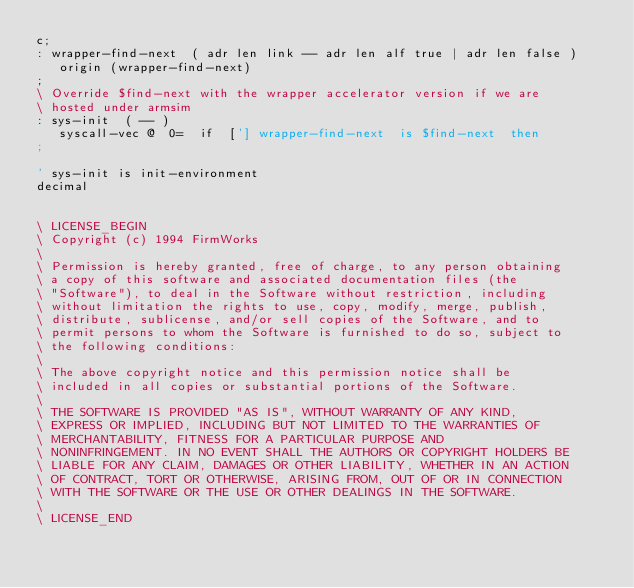<code> <loc_0><loc_0><loc_500><loc_500><_Forth_>c;
: wrapper-find-next  ( adr len link -- adr len alf true | adr len false )
   origin (wrapper-find-next)
;
\ Override $find-next with the wrapper accelerator version if we are
\ hosted under armsim
: sys-init  ( -- )
   syscall-vec @  0=  if  ['] wrapper-find-next  is $find-next  then
;

' sys-init is init-environment
decimal


\ LICENSE_BEGIN
\ Copyright (c) 1994 FirmWorks
\
\ Permission is hereby granted, free of charge, to any person obtaining
\ a copy of this software and associated documentation files (the
\ "Software"), to deal in the Software without restriction, including
\ without limitation the rights to use, copy, modify, merge, publish,
\ distribute, sublicense, and/or sell copies of the Software, and to
\ permit persons to whom the Software is furnished to do so, subject to
\ the following conditions:
\
\ The above copyright notice and this permission notice shall be
\ included in all copies or substantial portions of the Software.
\
\ THE SOFTWARE IS PROVIDED "AS IS", WITHOUT WARRANTY OF ANY KIND,
\ EXPRESS OR IMPLIED, INCLUDING BUT NOT LIMITED TO THE WARRANTIES OF
\ MERCHANTABILITY, FITNESS FOR A PARTICULAR PURPOSE AND
\ NONINFRINGEMENT. IN NO EVENT SHALL THE AUTHORS OR COPYRIGHT HOLDERS BE
\ LIABLE FOR ANY CLAIM, DAMAGES OR OTHER LIABILITY, WHETHER IN AN ACTION
\ OF CONTRACT, TORT OR OTHERWISE, ARISING FROM, OUT OF OR IN CONNECTION
\ WITH THE SOFTWARE OR THE USE OR OTHER DEALINGS IN THE SOFTWARE.
\
\ LICENSE_END
</code> 